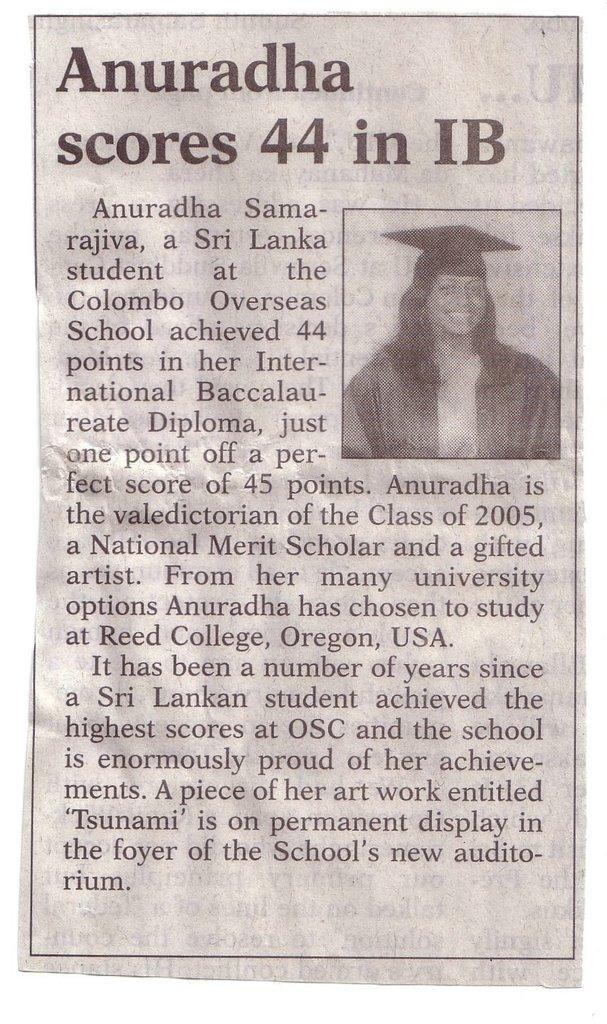What is the main subject of the image? There is a person in the image. Are there any words or letters in the image? Yes, there is text in the image. How is the image created? The image appears to be a paper cutting. What type of argument is the person having with the trousers in the image? There is no argument or trousers present in the image; it features a person and text in a paper cutting. What is the person using to fill the bucket in the image? There is no bucket or filling activity present in the image. 